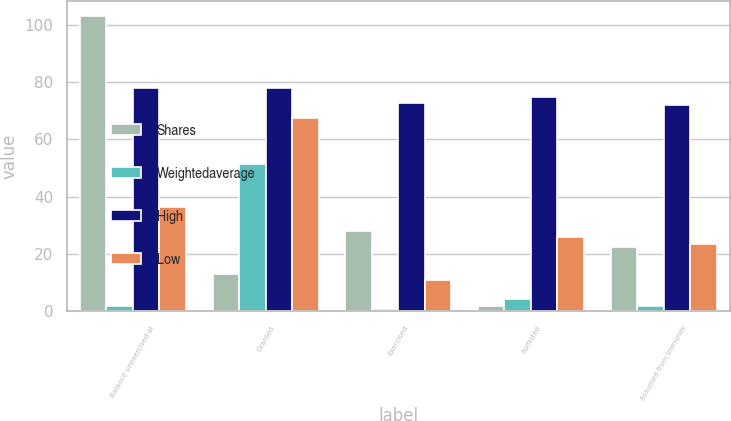<chart> <loc_0><loc_0><loc_500><loc_500><stacked_bar_chart><ecel><fcel>Balance unexercised at<fcel>Granted<fcel>Exercised<fcel>Forfeited<fcel>Assumed from Immunex<nl><fcel>Shares<fcel>103<fcel>13.1<fcel>28.2<fcel>2<fcel>22.4<nl><fcel>Weightedaverage<fcel>1.97<fcel>51.31<fcel>0.92<fcel>4.48<fcel>1.97<nl><fcel>High<fcel>78<fcel>78<fcel>72.75<fcel>74.86<fcel>72<nl><fcel>Low<fcel>36.25<fcel>67.4<fcel>11.03<fcel>26.02<fcel>23.66<nl></chart> 